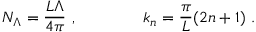Convert formula to latex. <formula><loc_0><loc_0><loc_500><loc_500>N _ { \Lambda } = \frac { L \Lambda } { 4 \pi } \ , \quad k _ { n } = \frac { \pi } { L } ( 2 n + 1 ) \ .</formula> 